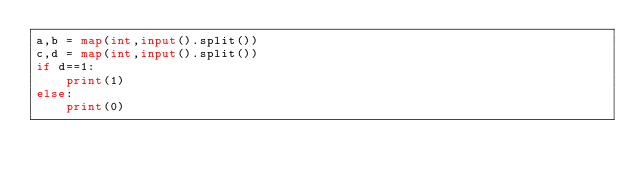<code> <loc_0><loc_0><loc_500><loc_500><_Python_>a,b = map(int,input().split())
c,d = map(int,input().split())
if d==1:
    print(1)
else:
    print(0)</code> 